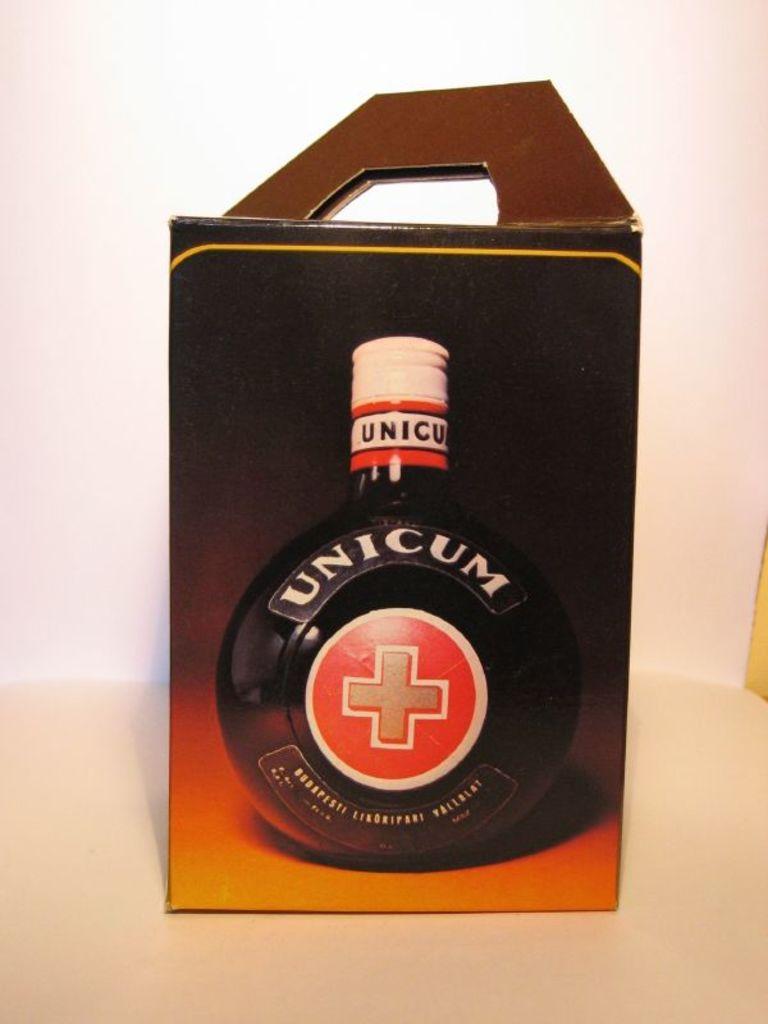What is the brand name?
Offer a terse response. Unicum. 